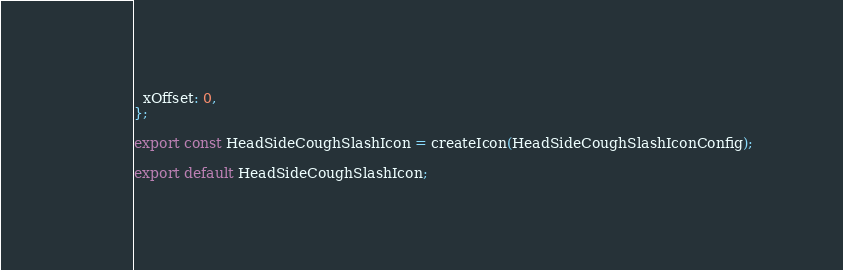<code> <loc_0><loc_0><loc_500><loc_500><_JavaScript_>  xOffset: 0,
};

export const HeadSideCoughSlashIcon = createIcon(HeadSideCoughSlashIconConfig);

export default HeadSideCoughSlashIcon;</code> 